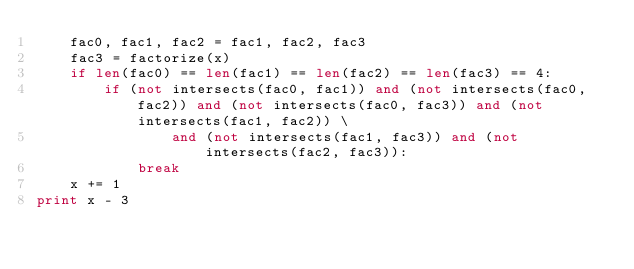Convert code to text. <code><loc_0><loc_0><loc_500><loc_500><_Python_>    fac0, fac1, fac2 = fac1, fac2, fac3
    fac3 = factorize(x)
    if len(fac0) == len(fac1) == len(fac2) == len(fac3) == 4:
        if (not intersects(fac0, fac1)) and (not intersects(fac0, fac2)) and (not intersects(fac0, fac3)) and (not intersects(fac1, fac2)) \
                and (not intersects(fac1, fac3)) and (not intersects(fac2, fac3)):
            break
    x += 1
print x - 3
</code> 